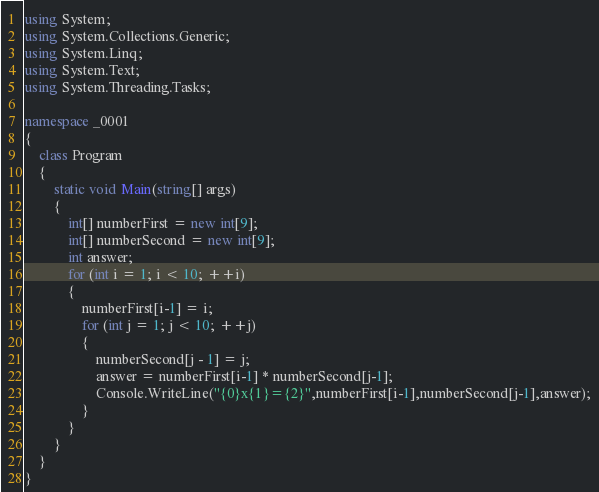Convert code to text. <code><loc_0><loc_0><loc_500><loc_500><_C#_>using System;
using System.Collections.Generic;
using System.Linq;
using System.Text;
using System.Threading.Tasks;

namespace _0001
{
    class Program
    {
        static void Main(string[] args)
        {
            int[] numberFirst = new int[9];
            int[] numberSecond = new int[9];
            int answer;
            for (int i = 1; i < 10; ++i)
            {
                numberFirst[i-1] = i;
                for (int j = 1; j < 10; ++j)
                {
                    numberSecond[j - 1] = j;
                    answer = numberFirst[i-1] * numberSecond[j-1];
                    Console.WriteLine("{0}x{1}={2}",numberFirst[i-1],numberSecond[j-1],answer);
                }
            }
        }
    }
}

</code> 